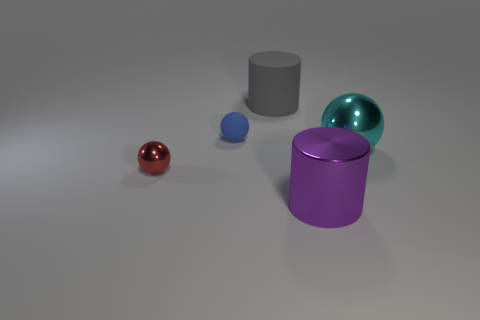What is the purple thing made of?
Offer a terse response. Metal. There is a matte thing in front of the big cylinder that is behind the big cylinder right of the large rubber thing; how big is it?
Provide a succinct answer. Small. There is a matte object on the left side of the big gray cylinder; does it have the same shape as the object that is behind the blue matte thing?
Keep it short and to the point. No. There is a object in front of the red shiny sphere; does it have the same size as the big cyan metal object?
Your answer should be compact. Yes. Does the big thing behind the large cyan metallic sphere have the same material as the red sphere that is behind the large purple metal cylinder?
Offer a very short reply. No. Are there any purple rubber spheres of the same size as the red metallic ball?
Your answer should be compact. No. What is the shape of the large object to the left of the shiny object in front of the metallic ball in front of the cyan shiny sphere?
Provide a short and direct response. Cylinder. Is the number of tiny blue things that are to the left of the large purple object greater than the number of brown rubber cubes?
Provide a succinct answer. Yes. Are there any big metallic things of the same shape as the blue matte thing?
Provide a succinct answer. Yes. Are the cyan ball and the object that is in front of the red thing made of the same material?
Provide a succinct answer. Yes. 